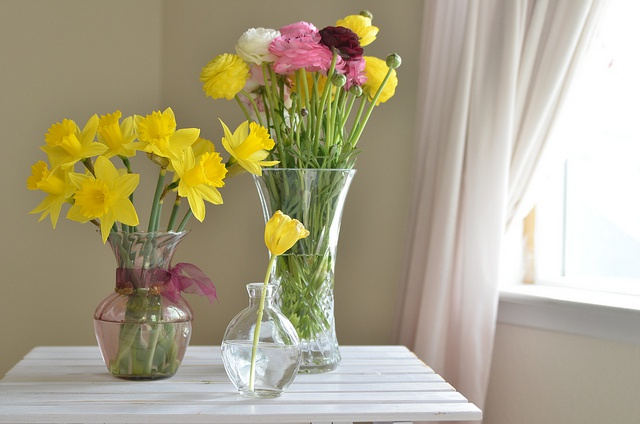Describe the objects in this image and their specific colors. I can see potted plant in gray and olive tones, dining table in gray, lightgray, and darkgray tones, vase in gray, darkgreen, olive, and lightgray tones, vase in gray and olive tones, and potted plant in gray, lightgray, and darkgray tones in this image. 